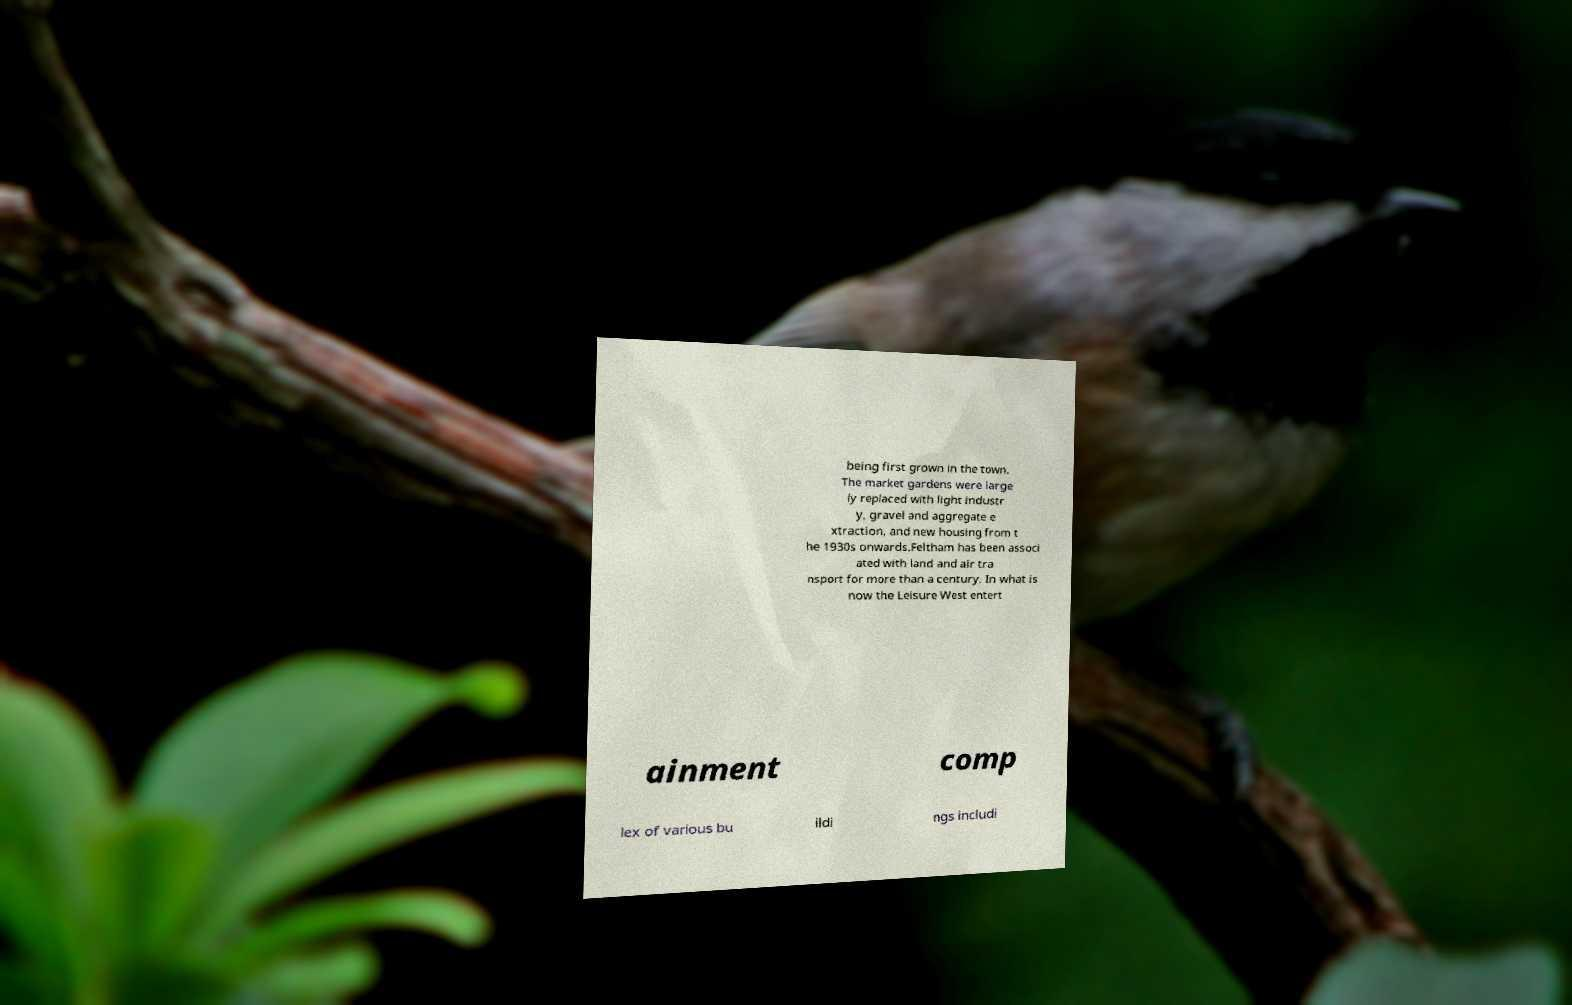Could you assist in decoding the text presented in this image and type it out clearly? being first grown in the town. The market gardens were large ly replaced with light industr y, gravel and aggregate e xtraction, and new housing from t he 1930s onwards.Feltham has been associ ated with land and air tra nsport for more than a century. In what is now the Leisure West entert ainment comp lex of various bu ildi ngs includi 